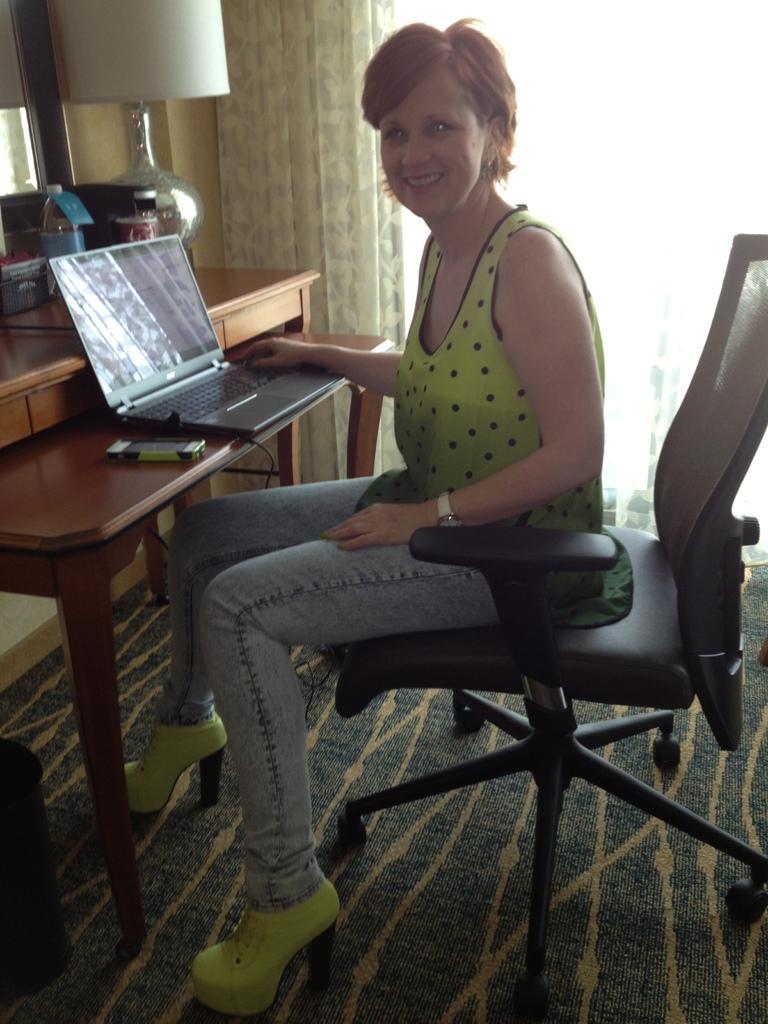Could you give a brief overview of what you see in this image? This picture is mainly highlighted with a woman sitting on a chair in front of a table and on the table we can see a laptop, mobile phone which is connected to a laptop, a table lamp, bottle. This is a floor. She is carrying a pretty smile on her face. This is a curtain and window. 